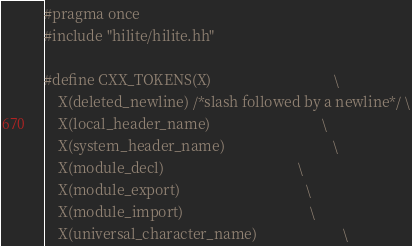<code> <loc_0><loc_0><loc_500><loc_500><_C++_>#pragma once
#include "hilite/hilite.hh"

#define CXX_TOKENS(X)                                  \
	X(deleted_newline) /*slash followed by a newline*/ \
	X(local_header_name)                               \
	X(system_header_name)                              \
	X(module_decl)                                     \
	X(module_export)                                   \
	X(module_import)                                   \
	X(universal_character_name)                        \</code> 